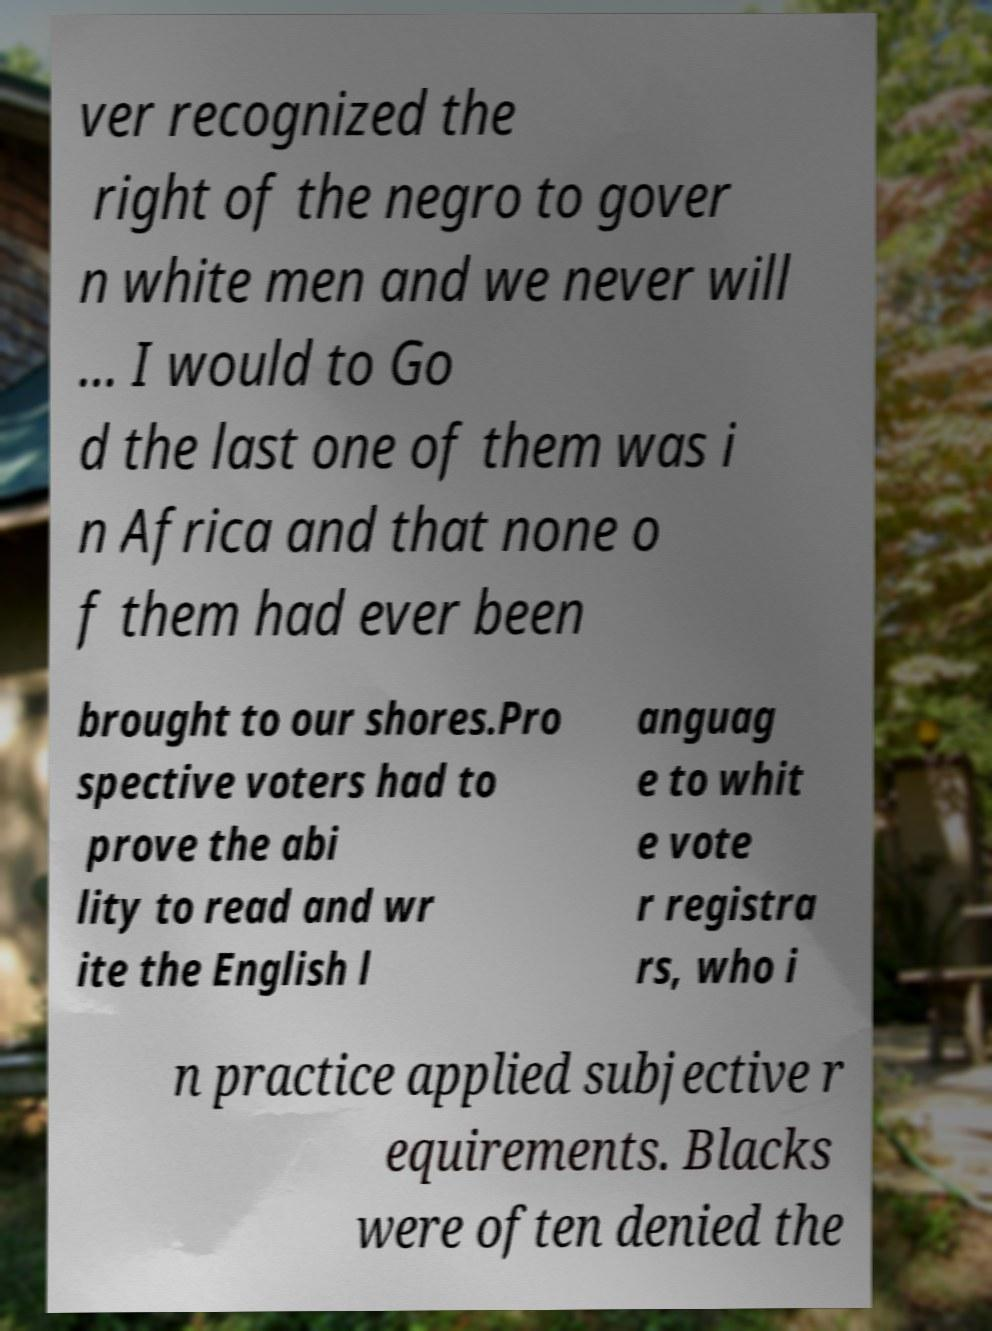Please identify and transcribe the text found in this image. ver recognized the right of the negro to gover n white men and we never will ... I would to Go d the last one of them was i n Africa and that none o f them had ever been brought to our shores.Pro spective voters had to prove the abi lity to read and wr ite the English l anguag e to whit e vote r registra rs, who i n practice applied subjective r equirements. Blacks were often denied the 